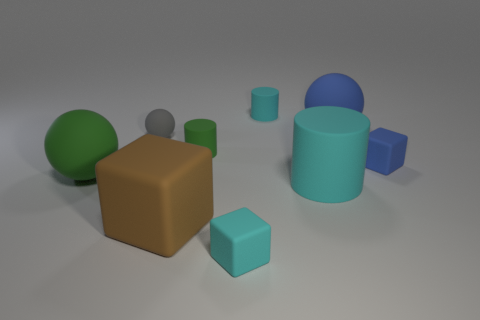Subtract all tiny cylinders. How many cylinders are left? 1 Subtract all blue spheres. How many cyan cylinders are left? 2 Add 1 big cyan objects. How many objects exist? 10 Subtract all cylinders. How many objects are left? 6 Subtract all yellow cubes. Subtract all gray cylinders. How many cubes are left? 3 Subtract all purple objects. Subtract all cubes. How many objects are left? 6 Add 6 big blocks. How many big blocks are left? 7 Add 5 big brown cubes. How many big brown cubes exist? 6 Subtract 0 brown balls. How many objects are left? 9 